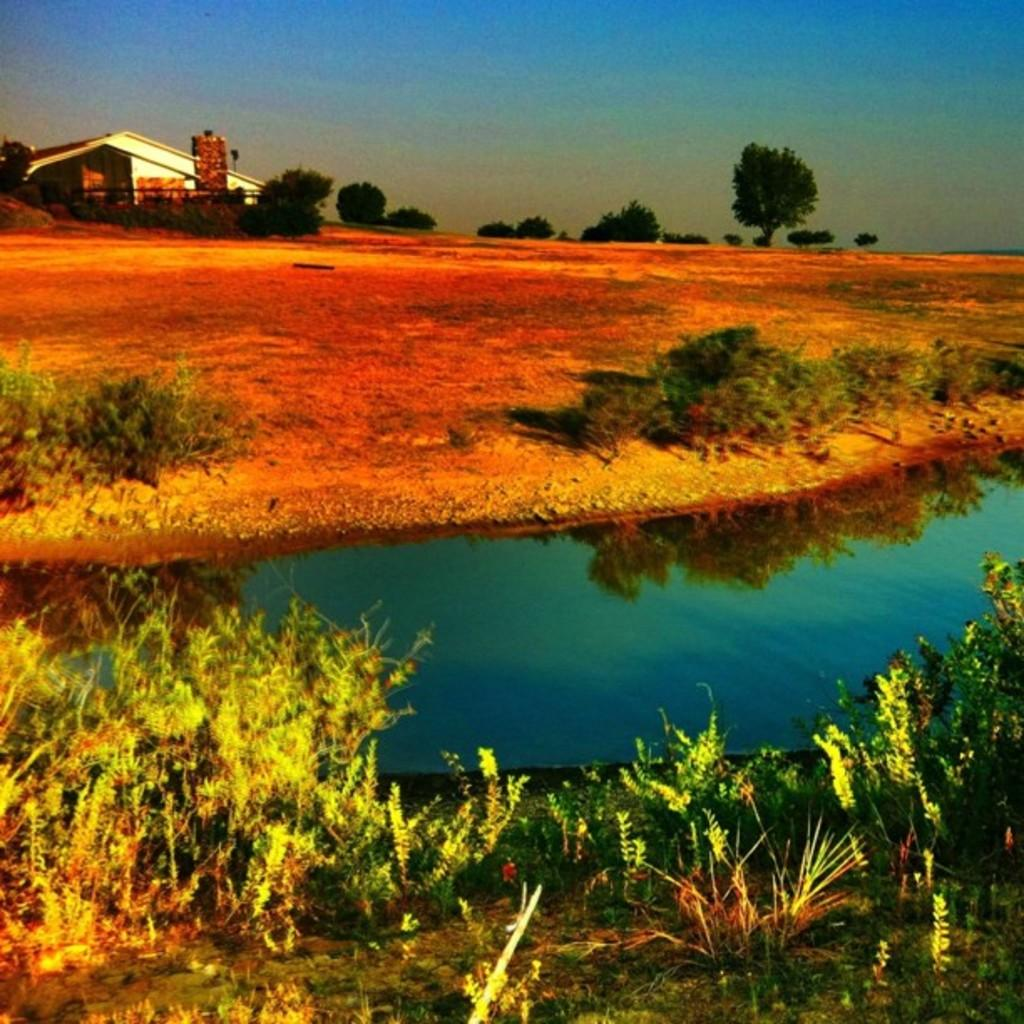What type of living organisms can be seen in the image? Plants and trees are visible in the image. What can be seen in the image besides plants and trees? There is water, a building, and the sky visible in the image. What is the natural setting visible in the image? The natural setting includes water, trees, and the sky. What verse is being recited by the tree in the image? There are no verses or any form of communication being depicted by the trees in the image. 